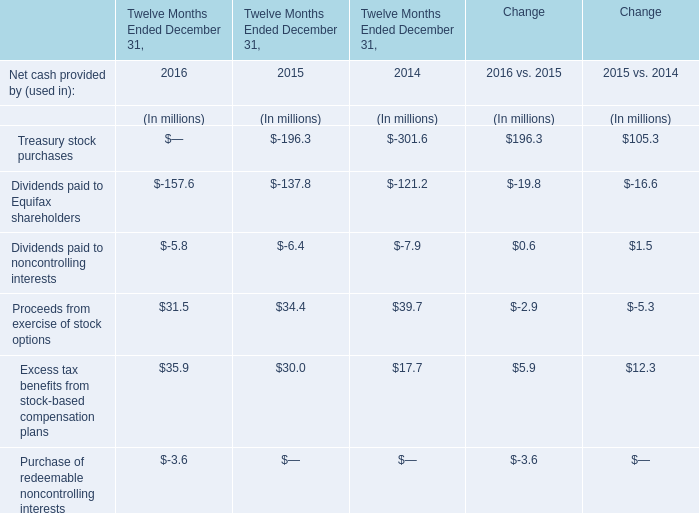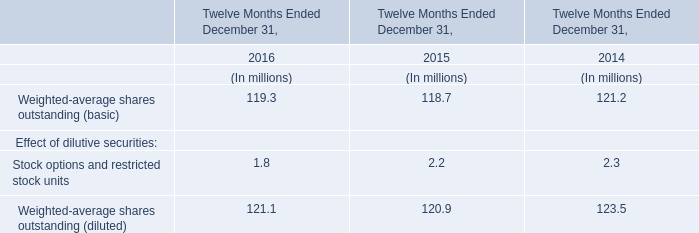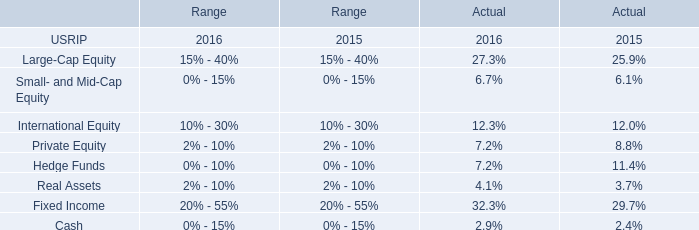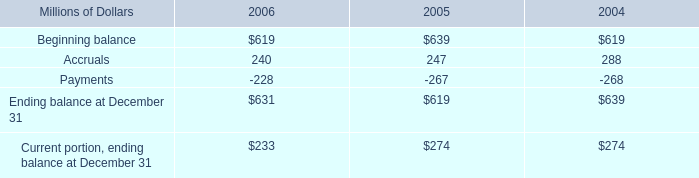What is the average value of Excess tax benefits from stock-based compensation plans in Table 0 and Stock options and restricted stock units in Table 1 in 2015? (in million) 
Computations: ((30 + 2.2) / 2)
Answer: 16.1. 